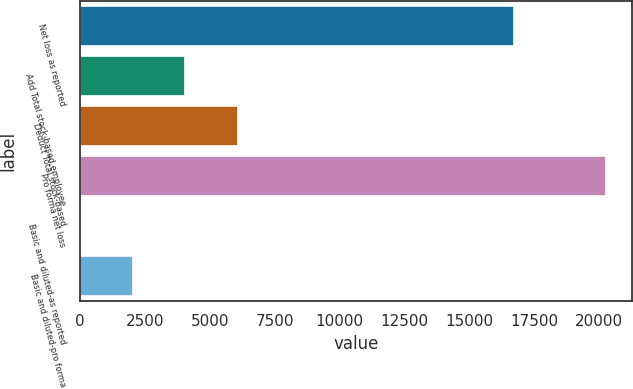Convert chart. <chart><loc_0><loc_0><loc_500><loc_500><bar_chart><fcel>Net loss as reported<fcel>Add Total stock-based employee<fcel>Deduct Total stock-based<fcel>Pro forma net loss<fcel>Basic and diluted-as reported<fcel>Basic and diluted-pro forma<nl><fcel>16700<fcel>4050.15<fcel>6074.76<fcel>20247<fcel>0.93<fcel>2025.54<nl></chart> 